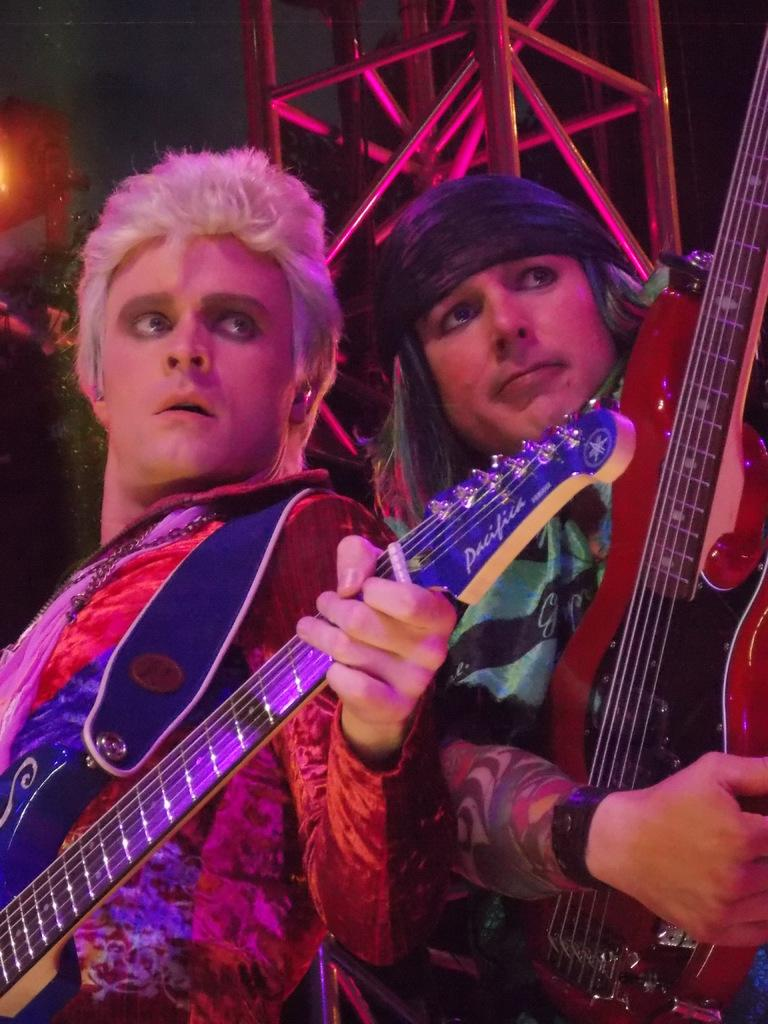How many people are in the image? There are two people in the image. What are the people wearing? The two people are wearing costumes. What are the people holding in the image? The people are holding musical instruments. What type of wall can be seen behind the people in the image? There is no wall visible in the image; it only shows two people wearing costumes and holding musical instruments. 